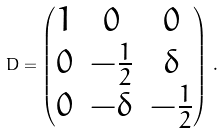Convert formula to latex. <formula><loc_0><loc_0><loc_500><loc_500>D = \begin{pmatrix} 1 & 0 & 0 \\ 0 & - \frac { 1 } { 2 } & \delta \\ 0 & - \delta & - \frac { 1 } { 2 } \end{pmatrix} \, .</formula> 